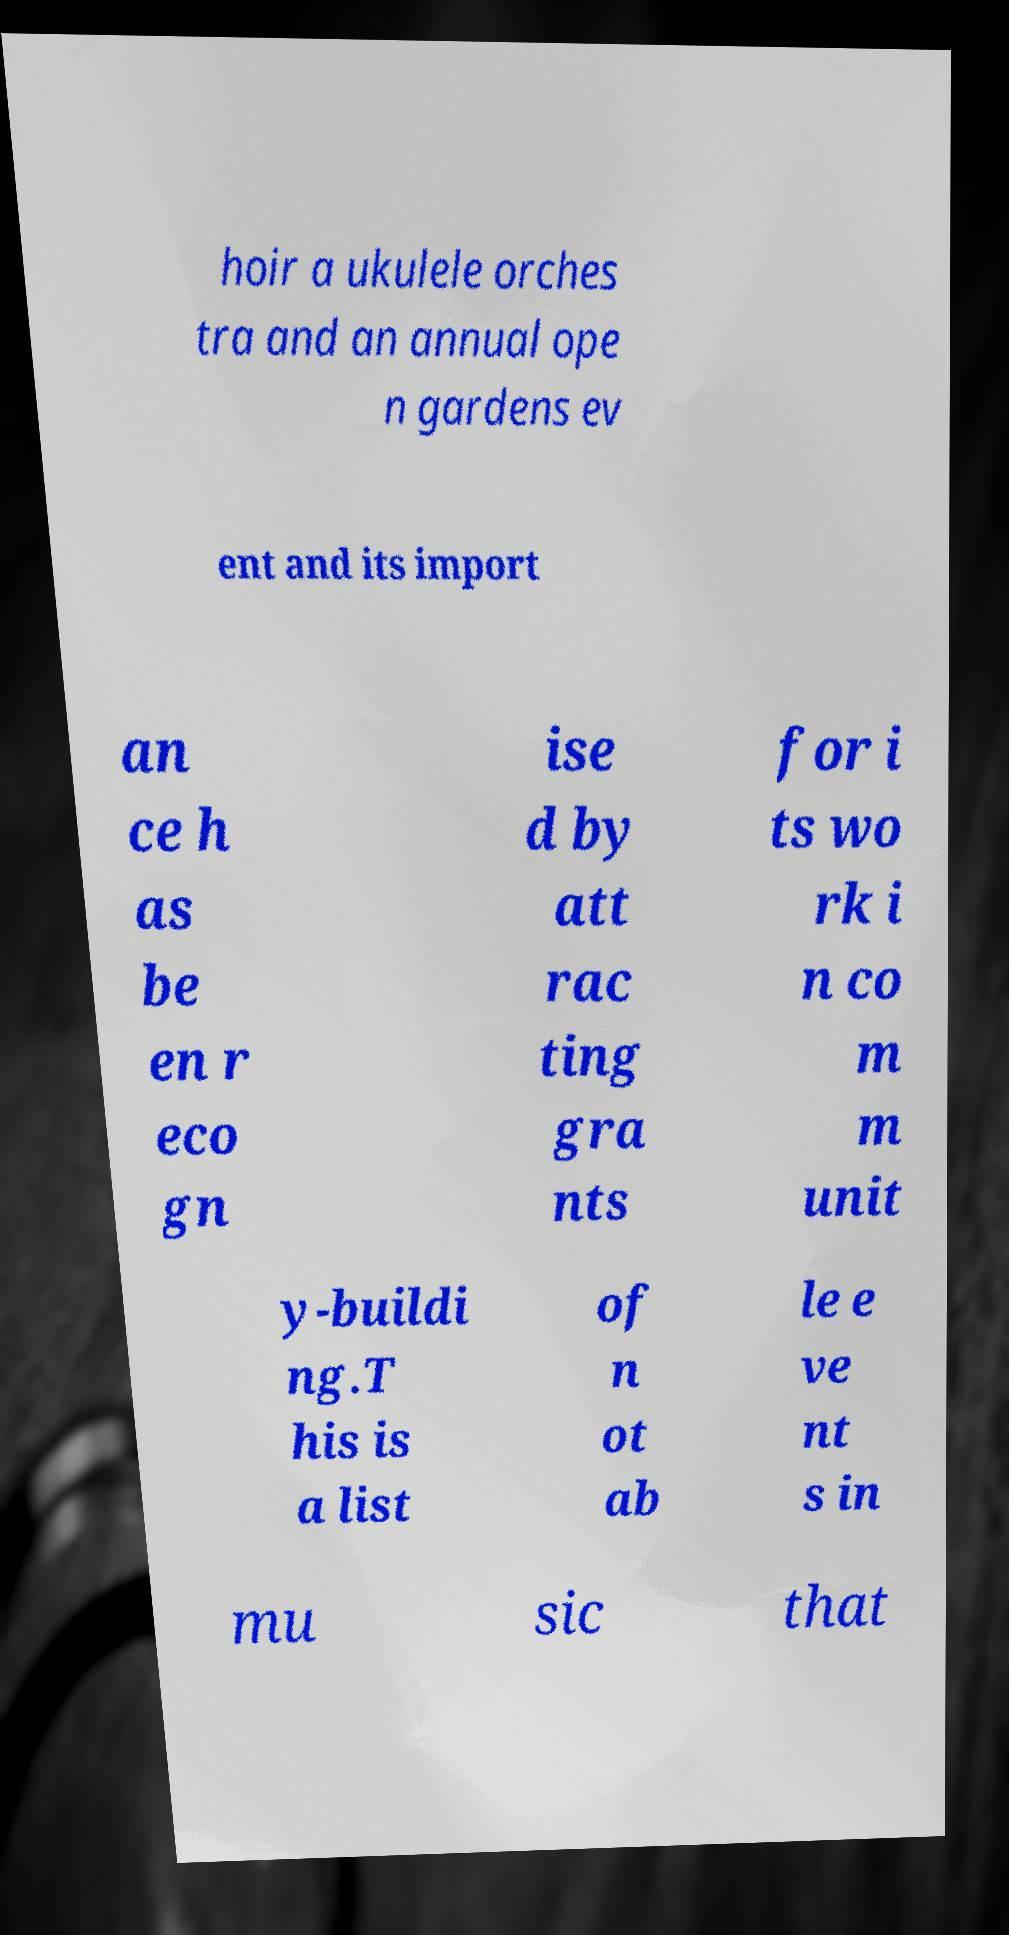Please read and relay the text visible in this image. What does it say? hoir a ukulele orches tra and an annual ope n gardens ev ent and its import an ce h as be en r eco gn ise d by att rac ting gra nts for i ts wo rk i n co m m unit y-buildi ng.T his is a list of n ot ab le e ve nt s in mu sic that 